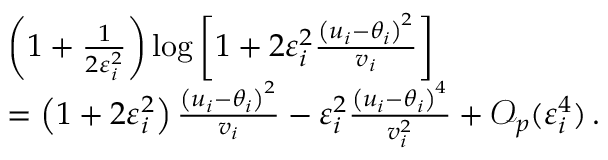Convert formula to latex. <formula><loc_0><loc_0><loc_500><loc_500>\begin{array} { r l } & { \left ( 1 + \frac { 1 } { 2 \varepsilon _ { i } ^ { 2 } } \right ) \log { \left [ 1 + 2 \varepsilon _ { i } ^ { 2 } \frac { \left ( u _ { i } - \theta _ { i } \right ) ^ { 2 } } { v _ { i } } \right ] } } \\ & { = \left ( 1 + 2 \varepsilon _ { i } ^ { 2 } \right ) \frac { \left ( u _ { i } - \theta _ { i } \right ) ^ { 2 } } { v _ { i } } - \varepsilon _ { i } ^ { 2 } \frac { \left ( u _ { i } - \theta _ { i } \right ) ^ { 4 } } { v _ { i } ^ { 2 } } + \mathcal { O } _ { p } ( \varepsilon _ { i } ^ { 4 } ) \, . } \end{array}</formula> 